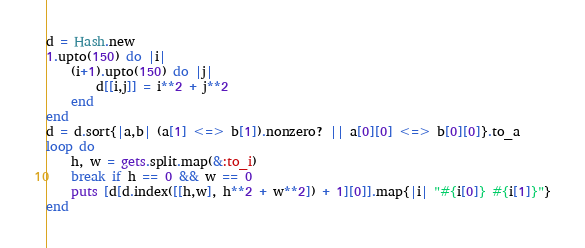Convert code to text. <code><loc_0><loc_0><loc_500><loc_500><_Ruby_>d = Hash.new
1.upto(150) do |i|
    (i+1).upto(150) do |j|
        d[[i,j]] = i**2 + j**2
    end
end
d = d.sort{|a,b| (a[1] <=> b[1]).nonzero? || a[0][0] <=> b[0][0]}.to_a
loop do
    h, w = gets.split.map(&:to_i)
    break if h == 0 && w == 0
    puts [d[d.index([[h,w], h**2 + w**2]) + 1][0]].map{|i| "#{i[0]} #{i[1]}"}
end</code> 